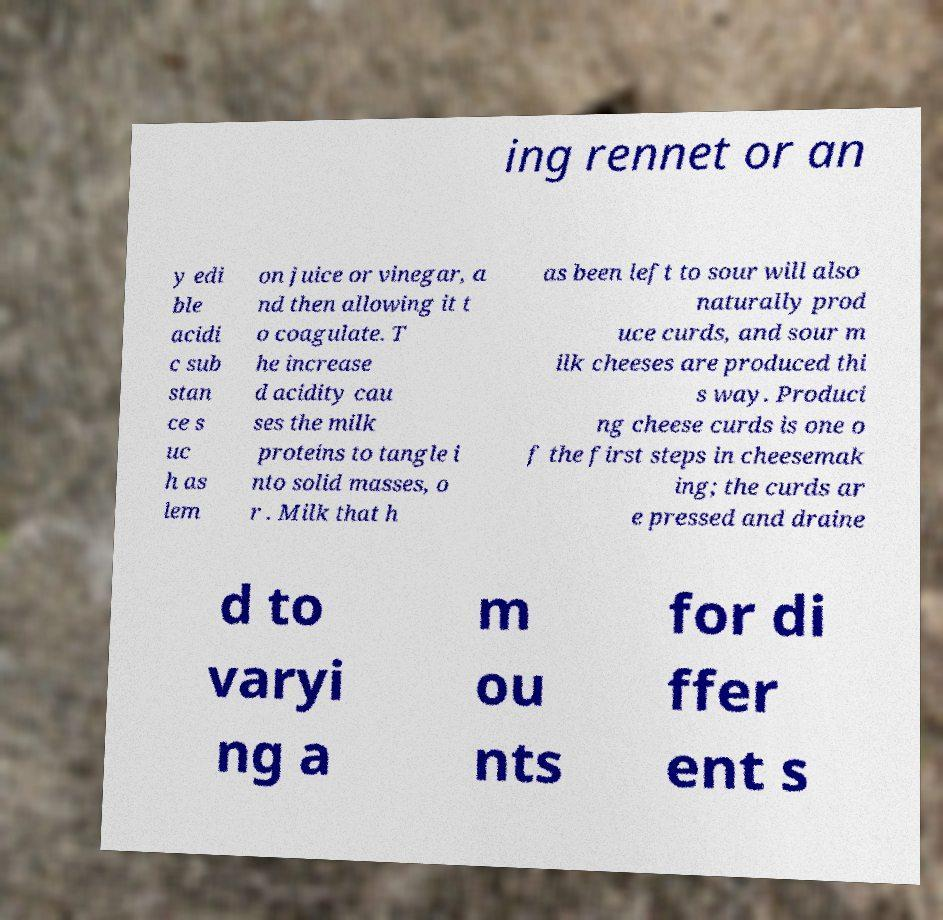What messages or text are displayed in this image? I need them in a readable, typed format. ing rennet or an y edi ble acidi c sub stan ce s uc h as lem on juice or vinegar, a nd then allowing it t o coagulate. T he increase d acidity cau ses the milk proteins to tangle i nto solid masses, o r . Milk that h as been left to sour will also naturally prod uce curds, and sour m ilk cheeses are produced thi s way. Produci ng cheese curds is one o f the first steps in cheesemak ing; the curds ar e pressed and draine d to varyi ng a m ou nts for di ffer ent s 